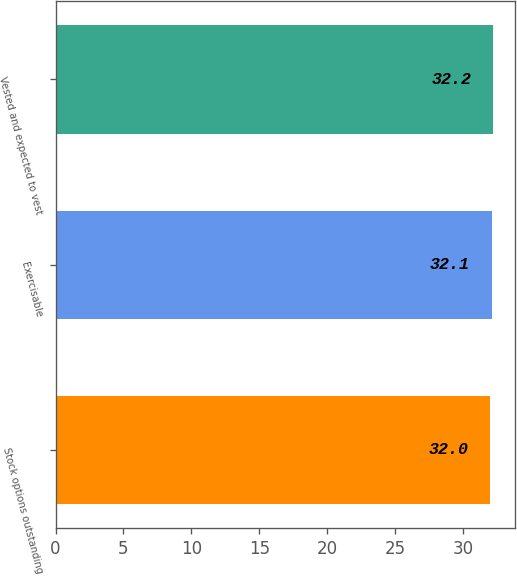<chart> <loc_0><loc_0><loc_500><loc_500><bar_chart><fcel>Stock options outstanding<fcel>Exercisable<fcel>Vested and expected to vest<nl><fcel>32<fcel>32.1<fcel>32.2<nl></chart> 